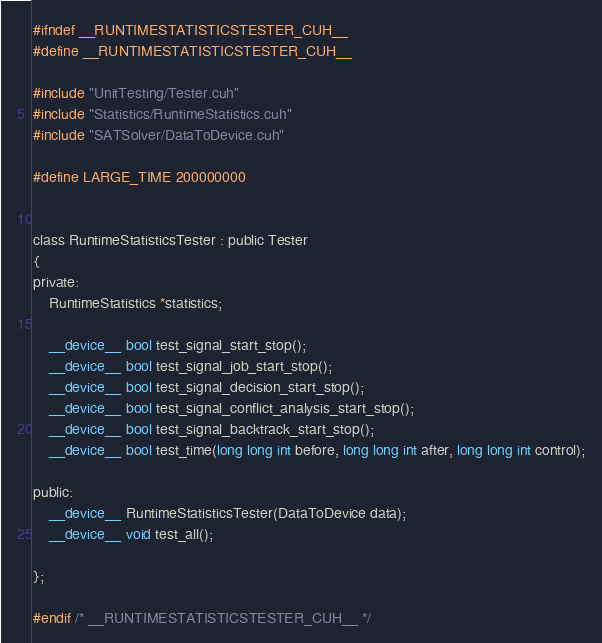Convert code to text. <code><loc_0><loc_0><loc_500><loc_500><_Cuda_>#ifndef __RUNTIMESTATISTICSTESTER_CUH__
#define __RUNTIMESTATISTICSTESTER_CUH__

#include "UnitTesting/Tester.cuh"
#include "Statistics/RuntimeStatistics.cuh"
#include "SATSolver/DataToDevice.cuh"

#define LARGE_TIME 200000000


class RuntimeStatisticsTester : public Tester
{
private:
    RuntimeStatistics *statistics;

    __device__ bool test_signal_start_stop();
    __device__ bool test_signal_job_start_stop();
    __device__ bool test_signal_decision_start_stop();
    __device__ bool test_signal_conflict_analysis_start_stop();
    __device__ bool test_signal_backtrack_start_stop();
    __device__ bool test_time(long long int before, long long int after, long long int control);

public:
    __device__ RuntimeStatisticsTester(DataToDevice data);
    __device__ void test_all();

};

#endif /* __RUNTIMESTATISTICSTESTER_CUH__ */
</code> 